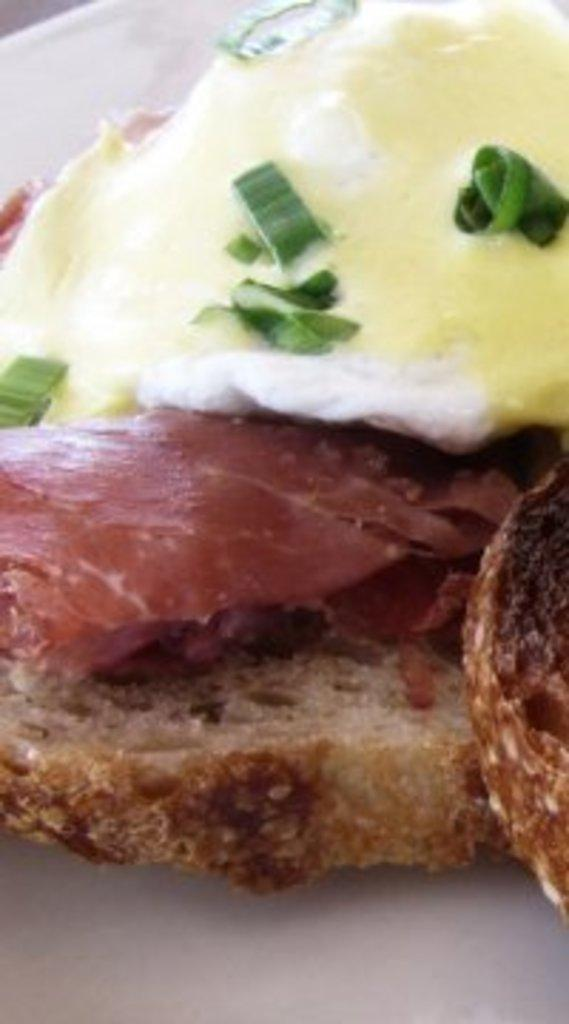What is present on the plate in the image? There is food in a plate in the image. What type of ear can be seen in the image? There is no ear present in the image; it features a plate of food. What time of day is depicted in the image? The time of day cannot be determined from the image, as it only shows a plate of food. 